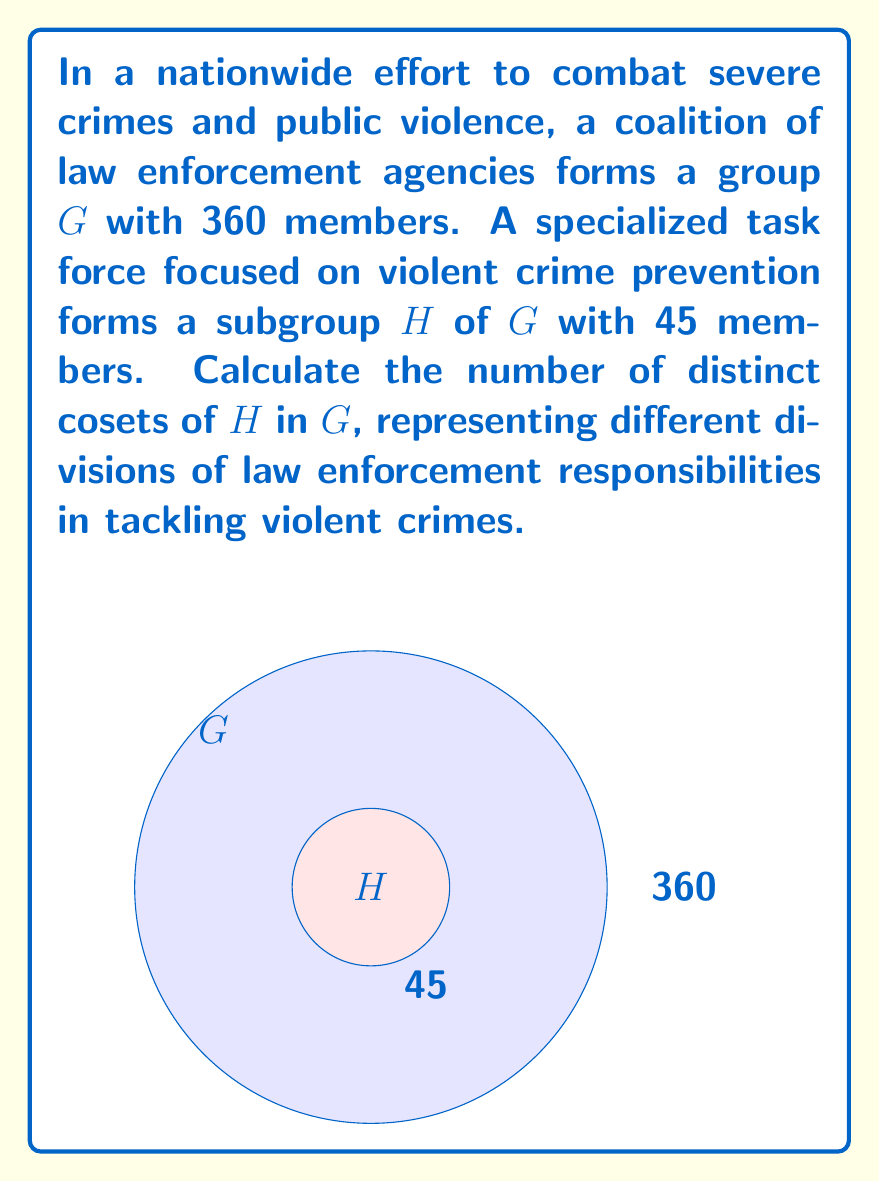Provide a solution to this math problem. To find the number of distinct cosets of $H$ in $G$, we can use the Lagrange's Theorem, which states that for a finite group $G$ and a subgroup $H$ of $G$, the order of $G$ is equal to the order of $H$ multiplied by the index of $H$ in $G$. The index of $H$ in $G$ is precisely the number of distinct cosets of $H$ in $G$.

Let's proceed step-by-step:

1) We are given:
   $|G| = 360$ (order of the full group)
   $|H| = 45$ (order of the subgroup)

2) Let $[G:H]$ denote the index of $H$ in $G$, which is the number of distinct cosets we're looking for.

3) By Lagrange's Theorem:
   $$|G| = |H| \cdot [G:H]$$

4) Substituting the known values:
   $$360 = 45 \cdot [G:H]$$

5) Solving for $[G:H]$:
   $$[G:H] = \frac{360}{45} = 8$$

Therefore, there are 8 distinct cosets of $H$ in $G$. Each coset represents a division of law enforcement responsibilities in tackling violent crimes, ensuring comprehensive coverage across different aspects of crime prevention and control.
Answer: $8$ cosets 